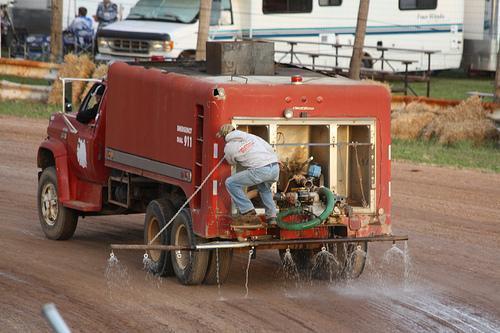How many people are pictured here?
Give a very brief answer. 3. 